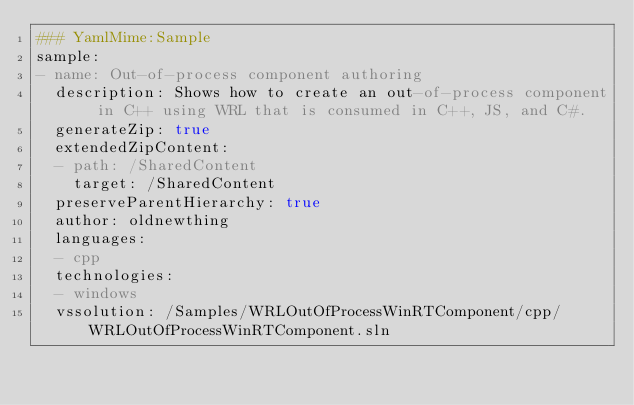<code> <loc_0><loc_0><loc_500><loc_500><_YAML_>### YamlMime:Sample
sample:
- name: Out-of-process component authoring
  description: Shows how to create an out-of-process component in C++ using WRL that is consumed in C++, JS, and C#.
  generateZip: true
  extendedZipContent:
  - path: /SharedContent
    target: /SharedContent
  preserveParentHierarchy: true
  author: oldnewthing
  languages:
  - cpp
  technologies:
  - windows
  vssolution: /Samples/WRLOutOfProcessWinRTComponent/cpp/WRLOutOfProcessWinRTComponent.sln
</code> 